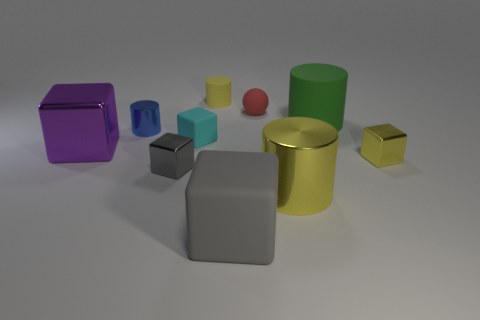There is a block that is on the left side of the blue cylinder; does it have the same color as the small thing to the right of the small sphere?
Your answer should be compact. No. Are there any big green matte cylinders in front of the big green object?
Your response must be concise. No. What is the color of the tiny thing that is in front of the big green cylinder and on the right side of the big rubber block?
Offer a terse response. Yellow. Are there any big shiny blocks that have the same color as the big matte cube?
Offer a very short reply. No. Do the tiny red thing that is to the right of the small blue metal cylinder and the cylinder that is behind the red ball have the same material?
Provide a succinct answer. Yes. What size is the block to the right of the green matte object?
Keep it short and to the point. Small. The gray metal block is what size?
Your response must be concise. Small. There is a rubber object that is in front of the small metal block that is on the right side of the small cylinder that is behind the tiny sphere; what size is it?
Give a very brief answer. Large. Is there a green cylinder that has the same material as the cyan object?
Your answer should be compact. Yes. There is a cyan rubber object; what shape is it?
Give a very brief answer. Cube. 